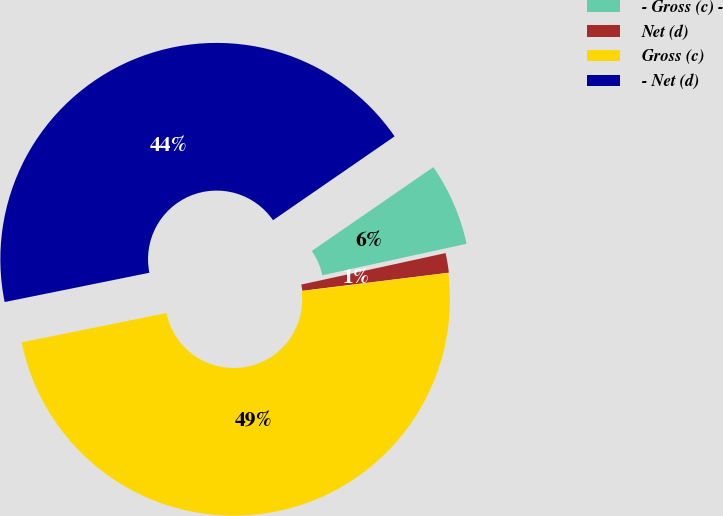Convert chart. <chart><loc_0><loc_0><loc_500><loc_500><pie_chart><fcel>- Gross (c) -<fcel>Net (d)<fcel>Gross (c)<fcel>- Net (d)<nl><fcel>6.19%<fcel>1.46%<fcel>48.78%<fcel>43.57%<nl></chart> 